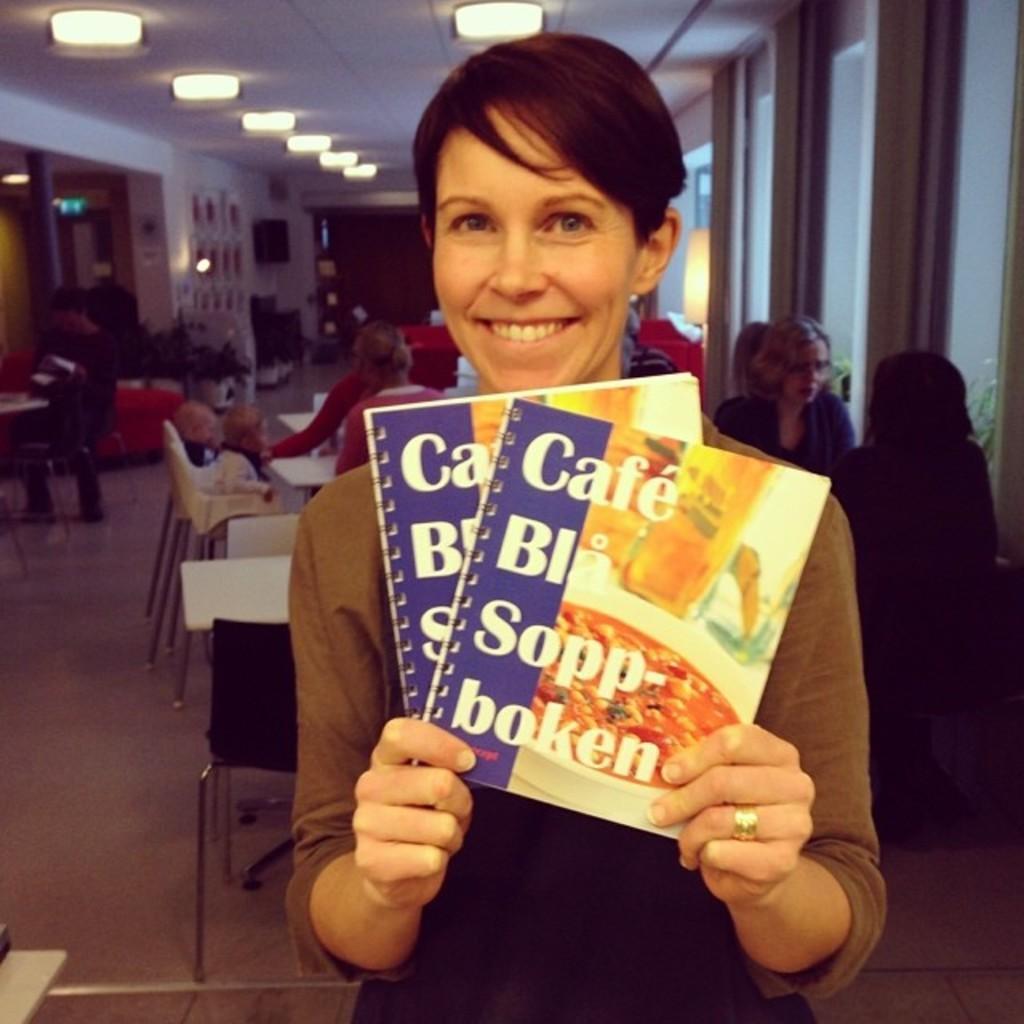Can you describe this image briefly? There is a lady holding book and smiling. In the back there are tables and chairs. Some people are sitting on the chairs. On the right side there are windows. On the ceiling there are lights. 